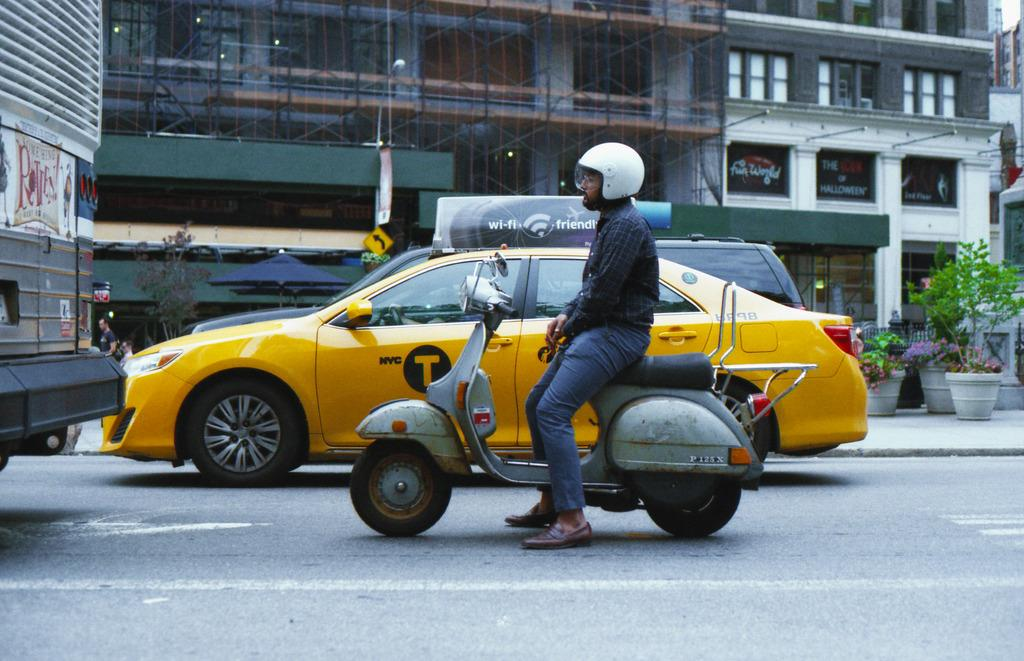<image>
Write a terse but informative summary of the picture. A man on a scooter sits next to a NYC Taxi which advertises as being Wi-Fi Friendly. 